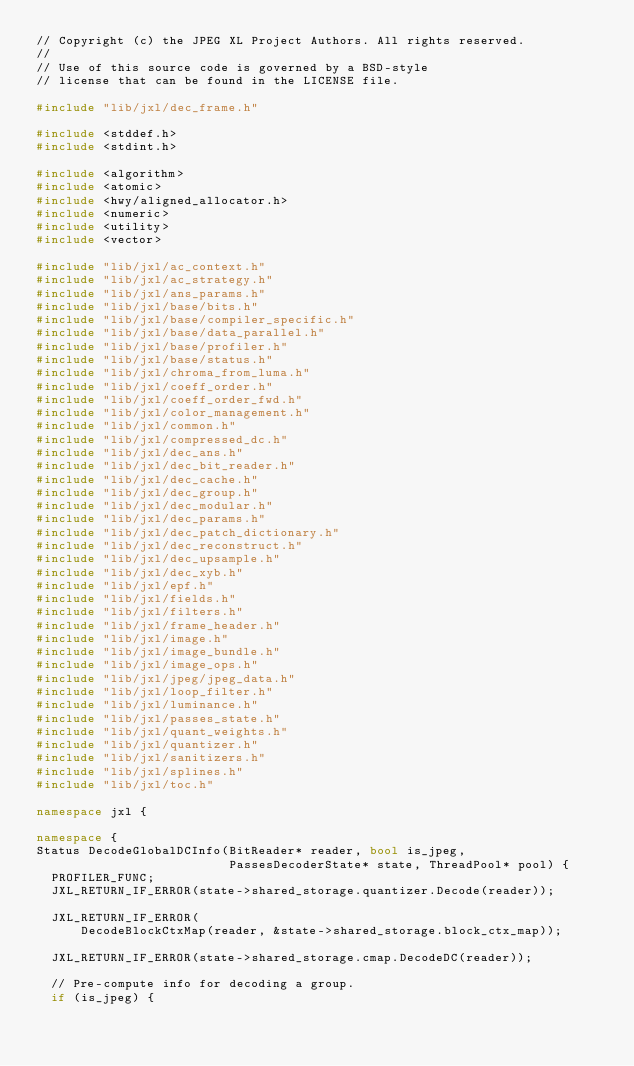Convert code to text. <code><loc_0><loc_0><loc_500><loc_500><_C++_>// Copyright (c) the JPEG XL Project Authors. All rights reserved.
//
// Use of this source code is governed by a BSD-style
// license that can be found in the LICENSE file.

#include "lib/jxl/dec_frame.h"

#include <stddef.h>
#include <stdint.h>

#include <algorithm>
#include <atomic>
#include <hwy/aligned_allocator.h>
#include <numeric>
#include <utility>
#include <vector>

#include "lib/jxl/ac_context.h"
#include "lib/jxl/ac_strategy.h"
#include "lib/jxl/ans_params.h"
#include "lib/jxl/base/bits.h"
#include "lib/jxl/base/compiler_specific.h"
#include "lib/jxl/base/data_parallel.h"
#include "lib/jxl/base/profiler.h"
#include "lib/jxl/base/status.h"
#include "lib/jxl/chroma_from_luma.h"
#include "lib/jxl/coeff_order.h"
#include "lib/jxl/coeff_order_fwd.h"
#include "lib/jxl/color_management.h"
#include "lib/jxl/common.h"
#include "lib/jxl/compressed_dc.h"
#include "lib/jxl/dec_ans.h"
#include "lib/jxl/dec_bit_reader.h"
#include "lib/jxl/dec_cache.h"
#include "lib/jxl/dec_group.h"
#include "lib/jxl/dec_modular.h"
#include "lib/jxl/dec_params.h"
#include "lib/jxl/dec_patch_dictionary.h"
#include "lib/jxl/dec_reconstruct.h"
#include "lib/jxl/dec_upsample.h"
#include "lib/jxl/dec_xyb.h"
#include "lib/jxl/epf.h"
#include "lib/jxl/fields.h"
#include "lib/jxl/filters.h"
#include "lib/jxl/frame_header.h"
#include "lib/jxl/image.h"
#include "lib/jxl/image_bundle.h"
#include "lib/jxl/image_ops.h"
#include "lib/jxl/jpeg/jpeg_data.h"
#include "lib/jxl/loop_filter.h"
#include "lib/jxl/luminance.h"
#include "lib/jxl/passes_state.h"
#include "lib/jxl/quant_weights.h"
#include "lib/jxl/quantizer.h"
#include "lib/jxl/sanitizers.h"
#include "lib/jxl/splines.h"
#include "lib/jxl/toc.h"

namespace jxl {

namespace {
Status DecodeGlobalDCInfo(BitReader* reader, bool is_jpeg,
                          PassesDecoderState* state, ThreadPool* pool) {
  PROFILER_FUNC;
  JXL_RETURN_IF_ERROR(state->shared_storage.quantizer.Decode(reader));

  JXL_RETURN_IF_ERROR(
      DecodeBlockCtxMap(reader, &state->shared_storage.block_ctx_map));

  JXL_RETURN_IF_ERROR(state->shared_storage.cmap.DecodeDC(reader));

  // Pre-compute info for decoding a group.
  if (is_jpeg) {</code> 